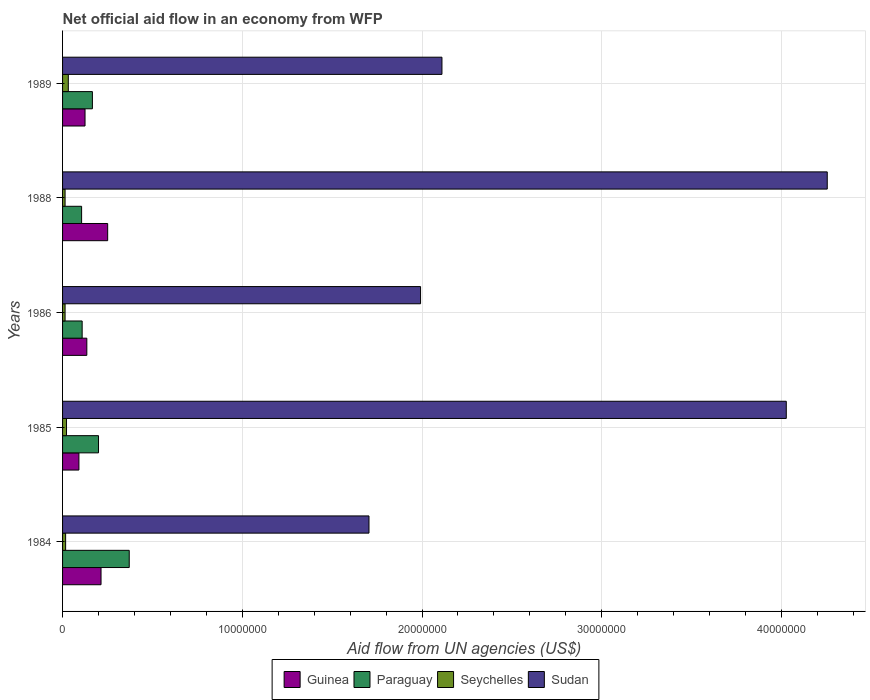Are the number of bars on each tick of the Y-axis equal?
Your answer should be very brief. Yes. What is the label of the 2nd group of bars from the top?
Ensure brevity in your answer.  1988. In how many cases, is the number of bars for a given year not equal to the number of legend labels?
Your response must be concise. 0. What is the net official aid flow in Sudan in 1988?
Give a very brief answer. 4.26e+07. Across all years, what is the maximum net official aid flow in Guinea?
Give a very brief answer. 2.51e+06. Across all years, what is the minimum net official aid flow in Guinea?
Your response must be concise. 9.10e+05. In which year was the net official aid flow in Sudan maximum?
Make the answer very short. 1988. In which year was the net official aid flow in Sudan minimum?
Your response must be concise. 1984. What is the total net official aid flow in Guinea in the graph?
Your response must be concise. 8.16e+06. What is the difference between the net official aid flow in Guinea in 1985 and that in 1988?
Provide a succinct answer. -1.60e+06. What is the difference between the net official aid flow in Sudan in 1986 and the net official aid flow in Guinea in 1984?
Make the answer very short. 1.78e+07. What is the average net official aid flow in Paraguay per year?
Offer a terse response. 1.90e+06. In the year 1984, what is the difference between the net official aid flow in Guinea and net official aid flow in Paraguay?
Your answer should be compact. -1.57e+06. In how many years, is the net official aid flow in Paraguay greater than 12000000 US$?
Keep it short and to the point. 0. What is the ratio of the net official aid flow in Seychelles in 1986 to that in 1989?
Offer a very short reply. 0.44. Is the net official aid flow in Paraguay in 1985 less than that in 1988?
Your answer should be very brief. No. Is the difference between the net official aid flow in Guinea in 1986 and 1988 greater than the difference between the net official aid flow in Paraguay in 1986 and 1988?
Provide a short and direct response. No. What is the difference between the highest and the second highest net official aid flow in Sudan?
Give a very brief answer. 2.28e+06. Is the sum of the net official aid flow in Seychelles in 1984 and 1986 greater than the maximum net official aid flow in Guinea across all years?
Provide a succinct answer. No. What does the 2nd bar from the top in 1984 represents?
Offer a terse response. Seychelles. What does the 3rd bar from the bottom in 1984 represents?
Offer a very short reply. Seychelles. How many bars are there?
Your response must be concise. 20. How many years are there in the graph?
Provide a succinct answer. 5. What is the difference between two consecutive major ticks on the X-axis?
Make the answer very short. 1.00e+07. Are the values on the major ticks of X-axis written in scientific E-notation?
Give a very brief answer. No. Does the graph contain grids?
Your answer should be very brief. Yes. How many legend labels are there?
Your answer should be very brief. 4. What is the title of the graph?
Your answer should be compact. Net official aid flow in an economy from WFP. What is the label or title of the X-axis?
Keep it short and to the point. Aid flow from UN agencies (US$). What is the label or title of the Y-axis?
Your answer should be compact. Years. What is the Aid flow from UN agencies (US$) in Guinea in 1984?
Give a very brief answer. 2.14e+06. What is the Aid flow from UN agencies (US$) of Paraguay in 1984?
Offer a very short reply. 3.71e+06. What is the Aid flow from UN agencies (US$) in Sudan in 1984?
Provide a succinct answer. 1.70e+07. What is the Aid flow from UN agencies (US$) in Guinea in 1985?
Keep it short and to the point. 9.10e+05. What is the Aid flow from UN agencies (US$) in Paraguay in 1985?
Provide a short and direct response. 2.00e+06. What is the Aid flow from UN agencies (US$) in Seychelles in 1985?
Make the answer very short. 2.20e+05. What is the Aid flow from UN agencies (US$) in Sudan in 1985?
Give a very brief answer. 4.03e+07. What is the Aid flow from UN agencies (US$) in Guinea in 1986?
Keep it short and to the point. 1.35e+06. What is the Aid flow from UN agencies (US$) in Paraguay in 1986?
Your response must be concise. 1.09e+06. What is the Aid flow from UN agencies (US$) in Seychelles in 1986?
Offer a terse response. 1.40e+05. What is the Aid flow from UN agencies (US$) of Sudan in 1986?
Your response must be concise. 1.99e+07. What is the Aid flow from UN agencies (US$) of Guinea in 1988?
Keep it short and to the point. 2.51e+06. What is the Aid flow from UN agencies (US$) in Paraguay in 1988?
Your response must be concise. 1.06e+06. What is the Aid flow from UN agencies (US$) of Seychelles in 1988?
Keep it short and to the point. 1.40e+05. What is the Aid flow from UN agencies (US$) of Sudan in 1988?
Your response must be concise. 4.26e+07. What is the Aid flow from UN agencies (US$) in Guinea in 1989?
Provide a short and direct response. 1.25e+06. What is the Aid flow from UN agencies (US$) of Paraguay in 1989?
Provide a succinct answer. 1.66e+06. What is the Aid flow from UN agencies (US$) of Sudan in 1989?
Keep it short and to the point. 2.11e+07. Across all years, what is the maximum Aid flow from UN agencies (US$) in Guinea?
Your answer should be compact. 2.51e+06. Across all years, what is the maximum Aid flow from UN agencies (US$) of Paraguay?
Your answer should be compact. 3.71e+06. Across all years, what is the maximum Aid flow from UN agencies (US$) in Sudan?
Offer a very short reply. 4.26e+07. Across all years, what is the minimum Aid flow from UN agencies (US$) of Guinea?
Ensure brevity in your answer.  9.10e+05. Across all years, what is the minimum Aid flow from UN agencies (US$) in Paraguay?
Offer a very short reply. 1.06e+06. Across all years, what is the minimum Aid flow from UN agencies (US$) in Sudan?
Your answer should be compact. 1.70e+07. What is the total Aid flow from UN agencies (US$) of Guinea in the graph?
Make the answer very short. 8.16e+06. What is the total Aid flow from UN agencies (US$) in Paraguay in the graph?
Your answer should be compact. 9.52e+06. What is the total Aid flow from UN agencies (US$) of Seychelles in the graph?
Your answer should be compact. 9.90e+05. What is the total Aid flow from UN agencies (US$) of Sudan in the graph?
Offer a terse response. 1.41e+08. What is the difference between the Aid flow from UN agencies (US$) of Guinea in 1984 and that in 1985?
Keep it short and to the point. 1.23e+06. What is the difference between the Aid flow from UN agencies (US$) of Paraguay in 1984 and that in 1985?
Give a very brief answer. 1.71e+06. What is the difference between the Aid flow from UN agencies (US$) in Sudan in 1984 and that in 1985?
Keep it short and to the point. -2.32e+07. What is the difference between the Aid flow from UN agencies (US$) in Guinea in 1984 and that in 1986?
Your answer should be very brief. 7.90e+05. What is the difference between the Aid flow from UN agencies (US$) of Paraguay in 1984 and that in 1986?
Your answer should be very brief. 2.62e+06. What is the difference between the Aid flow from UN agencies (US$) of Sudan in 1984 and that in 1986?
Provide a succinct answer. -2.87e+06. What is the difference between the Aid flow from UN agencies (US$) of Guinea in 1984 and that in 1988?
Your answer should be compact. -3.70e+05. What is the difference between the Aid flow from UN agencies (US$) in Paraguay in 1984 and that in 1988?
Your answer should be compact. 2.65e+06. What is the difference between the Aid flow from UN agencies (US$) of Sudan in 1984 and that in 1988?
Keep it short and to the point. -2.55e+07. What is the difference between the Aid flow from UN agencies (US$) of Guinea in 1984 and that in 1989?
Offer a terse response. 8.90e+05. What is the difference between the Aid flow from UN agencies (US$) of Paraguay in 1984 and that in 1989?
Offer a very short reply. 2.05e+06. What is the difference between the Aid flow from UN agencies (US$) of Sudan in 1984 and that in 1989?
Ensure brevity in your answer.  -4.06e+06. What is the difference between the Aid flow from UN agencies (US$) of Guinea in 1985 and that in 1986?
Provide a succinct answer. -4.40e+05. What is the difference between the Aid flow from UN agencies (US$) of Paraguay in 1985 and that in 1986?
Your answer should be very brief. 9.10e+05. What is the difference between the Aid flow from UN agencies (US$) of Seychelles in 1985 and that in 1986?
Provide a succinct answer. 8.00e+04. What is the difference between the Aid flow from UN agencies (US$) of Sudan in 1985 and that in 1986?
Give a very brief answer. 2.04e+07. What is the difference between the Aid flow from UN agencies (US$) of Guinea in 1985 and that in 1988?
Offer a terse response. -1.60e+06. What is the difference between the Aid flow from UN agencies (US$) in Paraguay in 1985 and that in 1988?
Offer a very short reply. 9.40e+05. What is the difference between the Aid flow from UN agencies (US$) in Seychelles in 1985 and that in 1988?
Your answer should be compact. 8.00e+04. What is the difference between the Aid flow from UN agencies (US$) in Sudan in 1985 and that in 1988?
Offer a very short reply. -2.28e+06. What is the difference between the Aid flow from UN agencies (US$) in Paraguay in 1985 and that in 1989?
Your answer should be compact. 3.40e+05. What is the difference between the Aid flow from UN agencies (US$) in Seychelles in 1985 and that in 1989?
Make the answer very short. -1.00e+05. What is the difference between the Aid flow from UN agencies (US$) in Sudan in 1985 and that in 1989?
Your response must be concise. 1.92e+07. What is the difference between the Aid flow from UN agencies (US$) in Guinea in 1986 and that in 1988?
Your response must be concise. -1.16e+06. What is the difference between the Aid flow from UN agencies (US$) in Paraguay in 1986 and that in 1988?
Your answer should be compact. 3.00e+04. What is the difference between the Aid flow from UN agencies (US$) in Sudan in 1986 and that in 1988?
Give a very brief answer. -2.26e+07. What is the difference between the Aid flow from UN agencies (US$) of Paraguay in 1986 and that in 1989?
Offer a terse response. -5.70e+05. What is the difference between the Aid flow from UN agencies (US$) of Seychelles in 1986 and that in 1989?
Your answer should be compact. -1.80e+05. What is the difference between the Aid flow from UN agencies (US$) in Sudan in 1986 and that in 1989?
Give a very brief answer. -1.19e+06. What is the difference between the Aid flow from UN agencies (US$) of Guinea in 1988 and that in 1989?
Your answer should be compact. 1.26e+06. What is the difference between the Aid flow from UN agencies (US$) in Paraguay in 1988 and that in 1989?
Give a very brief answer. -6.00e+05. What is the difference between the Aid flow from UN agencies (US$) in Sudan in 1988 and that in 1989?
Provide a short and direct response. 2.14e+07. What is the difference between the Aid flow from UN agencies (US$) in Guinea in 1984 and the Aid flow from UN agencies (US$) in Seychelles in 1985?
Provide a short and direct response. 1.92e+06. What is the difference between the Aid flow from UN agencies (US$) of Guinea in 1984 and the Aid flow from UN agencies (US$) of Sudan in 1985?
Provide a short and direct response. -3.81e+07. What is the difference between the Aid flow from UN agencies (US$) in Paraguay in 1984 and the Aid flow from UN agencies (US$) in Seychelles in 1985?
Your answer should be compact. 3.49e+06. What is the difference between the Aid flow from UN agencies (US$) of Paraguay in 1984 and the Aid flow from UN agencies (US$) of Sudan in 1985?
Give a very brief answer. -3.66e+07. What is the difference between the Aid flow from UN agencies (US$) of Seychelles in 1984 and the Aid flow from UN agencies (US$) of Sudan in 1985?
Provide a succinct answer. -4.01e+07. What is the difference between the Aid flow from UN agencies (US$) of Guinea in 1984 and the Aid flow from UN agencies (US$) of Paraguay in 1986?
Ensure brevity in your answer.  1.05e+06. What is the difference between the Aid flow from UN agencies (US$) in Guinea in 1984 and the Aid flow from UN agencies (US$) in Seychelles in 1986?
Your response must be concise. 2.00e+06. What is the difference between the Aid flow from UN agencies (US$) of Guinea in 1984 and the Aid flow from UN agencies (US$) of Sudan in 1986?
Make the answer very short. -1.78e+07. What is the difference between the Aid flow from UN agencies (US$) of Paraguay in 1984 and the Aid flow from UN agencies (US$) of Seychelles in 1986?
Your answer should be very brief. 3.57e+06. What is the difference between the Aid flow from UN agencies (US$) of Paraguay in 1984 and the Aid flow from UN agencies (US$) of Sudan in 1986?
Your answer should be compact. -1.62e+07. What is the difference between the Aid flow from UN agencies (US$) of Seychelles in 1984 and the Aid flow from UN agencies (US$) of Sudan in 1986?
Your answer should be compact. -1.98e+07. What is the difference between the Aid flow from UN agencies (US$) of Guinea in 1984 and the Aid flow from UN agencies (US$) of Paraguay in 1988?
Your response must be concise. 1.08e+06. What is the difference between the Aid flow from UN agencies (US$) of Guinea in 1984 and the Aid flow from UN agencies (US$) of Sudan in 1988?
Your answer should be very brief. -4.04e+07. What is the difference between the Aid flow from UN agencies (US$) of Paraguay in 1984 and the Aid flow from UN agencies (US$) of Seychelles in 1988?
Make the answer very short. 3.57e+06. What is the difference between the Aid flow from UN agencies (US$) in Paraguay in 1984 and the Aid flow from UN agencies (US$) in Sudan in 1988?
Your response must be concise. -3.88e+07. What is the difference between the Aid flow from UN agencies (US$) of Seychelles in 1984 and the Aid flow from UN agencies (US$) of Sudan in 1988?
Make the answer very short. -4.24e+07. What is the difference between the Aid flow from UN agencies (US$) in Guinea in 1984 and the Aid flow from UN agencies (US$) in Paraguay in 1989?
Make the answer very short. 4.80e+05. What is the difference between the Aid flow from UN agencies (US$) in Guinea in 1984 and the Aid flow from UN agencies (US$) in Seychelles in 1989?
Your answer should be compact. 1.82e+06. What is the difference between the Aid flow from UN agencies (US$) of Guinea in 1984 and the Aid flow from UN agencies (US$) of Sudan in 1989?
Provide a succinct answer. -1.90e+07. What is the difference between the Aid flow from UN agencies (US$) of Paraguay in 1984 and the Aid flow from UN agencies (US$) of Seychelles in 1989?
Offer a terse response. 3.39e+06. What is the difference between the Aid flow from UN agencies (US$) in Paraguay in 1984 and the Aid flow from UN agencies (US$) in Sudan in 1989?
Ensure brevity in your answer.  -1.74e+07. What is the difference between the Aid flow from UN agencies (US$) of Seychelles in 1984 and the Aid flow from UN agencies (US$) of Sudan in 1989?
Offer a very short reply. -2.09e+07. What is the difference between the Aid flow from UN agencies (US$) in Guinea in 1985 and the Aid flow from UN agencies (US$) in Seychelles in 1986?
Ensure brevity in your answer.  7.70e+05. What is the difference between the Aid flow from UN agencies (US$) in Guinea in 1985 and the Aid flow from UN agencies (US$) in Sudan in 1986?
Keep it short and to the point. -1.90e+07. What is the difference between the Aid flow from UN agencies (US$) in Paraguay in 1985 and the Aid flow from UN agencies (US$) in Seychelles in 1986?
Give a very brief answer. 1.86e+06. What is the difference between the Aid flow from UN agencies (US$) of Paraguay in 1985 and the Aid flow from UN agencies (US$) of Sudan in 1986?
Offer a very short reply. -1.79e+07. What is the difference between the Aid flow from UN agencies (US$) in Seychelles in 1985 and the Aid flow from UN agencies (US$) in Sudan in 1986?
Your answer should be very brief. -1.97e+07. What is the difference between the Aid flow from UN agencies (US$) of Guinea in 1985 and the Aid flow from UN agencies (US$) of Seychelles in 1988?
Provide a short and direct response. 7.70e+05. What is the difference between the Aid flow from UN agencies (US$) of Guinea in 1985 and the Aid flow from UN agencies (US$) of Sudan in 1988?
Give a very brief answer. -4.16e+07. What is the difference between the Aid flow from UN agencies (US$) in Paraguay in 1985 and the Aid flow from UN agencies (US$) in Seychelles in 1988?
Your answer should be very brief. 1.86e+06. What is the difference between the Aid flow from UN agencies (US$) of Paraguay in 1985 and the Aid flow from UN agencies (US$) of Sudan in 1988?
Your answer should be compact. -4.06e+07. What is the difference between the Aid flow from UN agencies (US$) in Seychelles in 1985 and the Aid flow from UN agencies (US$) in Sudan in 1988?
Offer a terse response. -4.23e+07. What is the difference between the Aid flow from UN agencies (US$) in Guinea in 1985 and the Aid flow from UN agencies (US$) in Paraguay in 1989?
Provide a succinct answer. -7.50e+05. What is the difference between the Aid flow from UN agencies (US$) in Guinea in 1985 and the Aid flow from UN agencies (US$) in Seychelles in 1989?
Provide a succinct answer. 5.90e+05. What is the difference between the Aid flow from UN agencies (US$) in Guinea in 1985 and the Aid flow from UN agencies (US$) in Sudan in 1989?
Provide a short and direct response. -2.02e+07. What is the difference between the Aid flow from UN agencies (US$) of Paraguay in 1985 and the Aid flow from UN agencies (US$) of Seychelles in 1989?
Offer a terse response. 1.68e+06. What is the difference between the Aid flow from UN agencies (US$) of Paraguay in 1985 and the Aid flow from UN agencies (US$) of Sudan in 1989?
Make the answer very short. -1.91e+07. What is the difference between the Aid flow from UN agencies (US$) of Seychelles in 1985 and the Aid flow from UN agencies (US$) of Sudan in 1989?
Your answer should be compact. -2.09e+07. What is the difference between the Aid flow from UN agencies (US$) in Guinea in 1986 and the Aid flow from UN agencies (US$) in Seychelles in 1988?
Make the answer very short. 1.21e+06. What is the difference between the Aid flow from UN agencies (US$) of Guinea in 1986 and the Aid flow from UN agencies (US$) of Sudan in 1988?
Make the answer very short. -4.12e+07. What is the difference between the Aid flow from UN agencies (US$) of Paraguay in 1986 and the Aid flow from UN agencies (US$) of Seychelles in 1988?
Offer a terse response. 9.50e+05. What is the difference between the Aid flow from UN agencies (US$) of Paraguay in 1986 and the Aid flow from UN agencies (US$) of Sudan in 1988?
Give a very brief answer. -4.15e+07. What is the difference between the Aid flow from UN agencies (US$) in Seychelles in 1986 and the Aid flow from UN agencies (US$) in Sudan in 1988?
Offer a very short reply. -4.24e+07. What is the difference between the Aid flow from UN agencies (US$) of Guinea in 1986 and the Aid flow from UN agencies (US$) of Paraguay in 1989?
Provide a succinct answer. -3.10e+05. What is the difference between the Aid flow from UN agencies (US$) in Guinea in 1986 and the Aid flow from UN agencies (US$) in Seychelles in 1989?
Offer a terse response. 1.03e+06. What is the difference between the Aid flow from UN agencies (US$) in Guinea in 1986 and the Aid flow from UN agencies (US$) in Sudan in 1989?
Give a very brief answer. -1.98e+07. What is the difference between the Aid flow from UN agencies (US$) in Paraguay in 1986 and the Aid flow from UN agencies (US$) in Seychelles in 1989?
Your response must be concise. 7.70e+05. What is the difference between the Aid flow from UN agencies (US$) of Paraguay in 1986 and the Aid flow from UN agencies (US$) of Sudan in 1989?
Ensure brevity in your answer.  -2.00e+07. What is the difference between the Aid flow from UN agencies (US$) in Seychelles in 1986 and the Aid flow from UN agencies (US$) in Sudan in 1989?
Keep it short and to the point. -2.10e+07. What is the difference between the Aid flow from UN agencies (US$) in Guinea in 1988 and the Aid flow from UN agencies (US$) in Paraguay in 1989?
Provide a succinct answer. 8.50e+05. What is the difference between the Aid flow from UN agencies (US$) in Guinea in 1988 and the Aid flow from UN agencies (US$) in Seychelles in 1989?
Offer a very short reply. 2.19e+06. What is the difference between the Aid flow from UN agencies (US$) of Guinea in 1988 and the Aid flow from UN agencies (US$) of Sudan in 1989?
Keep it short and to the point. -1.86e+07. What is the difference between the Aid flow from UN agencies (US$) in Paraguay in 1988 and the Aid flow from UN agencies (US$) in Seychelles in 1989?
Provide a succinct answer. 7.40e+05. What is the difference between the Aid flow from UN agencies (US$) in Paraguay in 1988 and the Aid flow from UN agencies (US$) in Sudan in 1989?
Offer a terse response. -2.00e+07. What is the difference between the Aid flow from UN agencies (US$) of Seychelles in 1988 and the Aid flow from UN agencies (US$) of Sudan in 1989?
Offer a very short reply. -2.10e+07. What is the average Aid flow from UN agencies (US$) in Guinea per year?
Offer a very short reply. 1.63e+06. What is the average Aid flow from UN agencies (US$) of Paraguay per year?
Your answer should be compact. 1.90e+06. What is the average Aid flow from UN agencies (US$) of Seychelles per year?
Your answer should be very brief. 1.98e+05. What is the average Aid flow from UN agencies (US$) of Sudan per year?
Your response must be concise. 2.82e+07. In the year 1984, what is the difference between the Aid flow from UN agencies (US$) of Guinea and Aid flow from UN agencies (US$) of Paraguay?
Make the answer very short. -1.57e+06. In the year 1984, what is the difference between the Aid flow from UN agencies (US$) in Guinea and Aid flow from UN agencies (US$) in Seychelles?
Your answer should be compact. 1.97e+06. In the year 1984, what is the difference between the Aid flow from UN agencies (US$) in Guinea and Aid flow from UN agencies (US$) in Sudan?
Provide a short and direct response. -1.49e+07. In the year 1984, what is the difference between the Aid flow from UN agencies (US$) of Paraguay and Aid flow from UN agencies (US$) of Seychelles?
Give a very brief answer. 3.54e+06. In the year 1984, what is the difference between the Aid flow from UN agencies (US$) in Paraguay and Aid flow from UN agencies (US$) in Sudan?
Ensure brevity in your answer.  -1.33e+07. In the year 1984, what is the difference between the Aid flow from UN agencies (US$) of Seychelles and Aid flow from UN agencies (US$) of Sudan?
Your answer should be very brief. -1.69e+07. In the year 1985, what is the difference between the Aid flow from UN agencies (US$) in Guinea and Aid flow from UN agencies (US$) in Paraguay?
Keep it short and to the point. -1.09e+06. In the year 1985, what is the difference between the Aid flow from UN agencies (US$) in Guinea and Aid flow from UN agencies (US$) in Seychelles?
Keep it short and to the point. 6.90e+05. In the year 1985, what is the difference between the Aid flow from UN agencies (US$) in Guinea and Aid flow from UN agencies (US$) in Sudan?
Ensure brevity in your answer.  -3.94e+07. In the year 1985, what is the difference between the Aid flow from UN agencies (US$) of Paraguay and Aid flow from UN agencies (US$) of Seychelles?
Ensure brevity in your answer.  1.78e+06. In the year 1985, what is the difference between the Aid flow from UN agencies (US$) of Paraguay and Aid flow from UN agencies (US$) of Sudan?
Your response must be concise. -3.83e+07. In the year 1985, what is the difference between the Aid flow from UN agencies (US$) in Seychelles and Aid flow from UN agencies (US$) in Sudan?
Ensure brevity in your answer.  -4.00e+07. In the year 1986, what is the difference between the Aid flow from UN agencies (US$) in Guinea and Aid flow from UN agencies (US$) in Paraguay?
Provide a succinct answer. 2.60e+05. In the year 1986, what is the difference between the Aid flow from UN agencies (US$) of Guinea and Aid flow from UN agencies (US$) of Seychelles?
Keep it short and to the point. 1.21e+06. In the year 1986, what is the difference between the Aid flow from UN agencies (US$) in Guinea and Aid flow from UN agencies (US$) in Sudan?
Keep it short and to the point. -1.86e+07. In the year 1986, what is the difference between the Aid flow from UN agencies (US$) of Paraguay and Aid flow from UN agencies (US$) of Seychelles?
Give a very brief answer. 9.50e+05. In the year 1986, what is the difference between the Aid flow from UN agencies (US$) in Paraguay and Aid flow from UN agencies (US$) in Sudan?
Offer a very short reply. -1.88e+07. In the year 1986, what is the difference between the Aid flow from UN agencies (US$) in Seychelles and Aid flow from UN agencies (US$) in Sudan?
Offer a terse response. -1.98e+07. In the year 1988, what is the difference between the Aid flow from UN agencies (US$) in Guinea and Aid flow from UN agencies (US$) in Paraguay?
Your answer should be compact. 1.45e+06. In the year 1988, what is the difference between the Aid flow from UN agencies (US$) in Guinea and Aid flow from UN agencies (US$) in Seychelles?
Offer a terse response. 2.37e+06. In the year 1988, what is the difference between the Aid flow from UN agencies (US$) of Guinea and Aid flow from UN agencies (US$) of Sudan?
Keep it short and to the point. -4.00e+07. In the year 1988, what is the difference between the Aid flow from UN agencies (US$) in Paraguay and Aid flow from UN agencies (US$) in Seychelles?
Provide a succinct answer. 9.20e+05. In the year 1988, what is the difference between the Aid flow from UN agencies (US$) of Paraguay and Aid flow from UN agencies (US$) of Sudan?
Give a very brief answer. -4.15e+07. In the year 1988, what is the difference between the Aid flow from UN agencies (US$) of Seychelles and Aid flow from UN agencies (US$) of Sudan?
Your answer should be compact. -4.24e+07. In the year 1989, what is the difference between the Aid flow from UN agencies (US$) of Guinea and Aid flow from UN agencies (US$) of Paraguay?
Ensure brevity in your answer.  -4.10e+05. In the year 1989, what is the difference between the Aid flow from UN agencies (US$) in Guinea and Aid flow from UN agencies (US$) in Seychelles?
Ensure brevity in your answer.  9.30e+05. In the year 1989, what is the difference between the Aid flow from UN agencies (US$) in Guinea and Aid flow from UN agencies (US$) in Sudan?
Your answer should be compact. -1.99e+07. In the year 1989, what is the difference between the Aid flow from UN agencies (US$) of Paraguay and Aid flow from UN agencies (US$) of Seychelles?
Your answer should be compact. 1.34e+06. In the year 1989, what is the difference between the Aid flow from UN agencies (US$) in Paraguay and Aid flow from UN agencies (US$) in Sudan?
Give a very brief answer. -1.94e+07. In the year 1989, what is the difference between the Aid flow from UN agencies (US$) in Seychelles and Aid flow from UN agencies (US$) in Sudan?
Ensure brevity in your answer.  -2.08e+07. What is the ratio of the Aid flow from UN agencies (US$) of Guinea in 1984 to that in 1985?
Provide a short and direct response. 2.35. What is the ratio of the Aid flow from UN agencies (US$) of Paraguay in 1984 to that in 1985?
Ensure brevity in your answer.  1.85. What is the ratio of the Aid flow from UN agencies (US$) of Seychelles in 1984 to that in 1985?
Offer a very short reply. 0.77. What is the ratio of the Aid flow from UN agencies (US$) in Sudan in 1984 to that in 1985?
Keep it short and to the point. 0.42. What is the ratio of the Aid flow from UN agencies (US$) in Guinea in 1984 to that in 1986?
Your answer should be compact. 1.59. What is the ratio of the Aid flow from UN agencies (US$) in Paraguay in 1984 to that in 1986?
Give a very brief answer. 3.4. What is the ratio of the Aid flow from UN agencies (US$) of Seychelles in 1984 to that in 1986?
Your answer should be very brief. 1.21. What is the ratio of the Aid flow from UN agencies (US$) of Sudan in 1984 to that in 1986?
Offer a terse response. 0.86. What is the ratio of the Aid flow from UN agencies (US$) in Guinea in 1984 to that in 1988?
Offer a very short reply. 0.85. What is the ratio of the Aid flow from UN agencies (US$) in Paraguay in 1984 to that in 1988?
Make the answer very short. 3.5. What is the ratio of the Aid flow from UN agencies (US$) of Seychelles in 1984 to that in 1988?
Make the answer very short. 1.21. What is the ratio of the Aid flow from UN agencies (US$) of Sudan in 1984 to that in 1988?
Give a very brief answer. 0.4. What is the ratio of the Aid flow from UN agencies (US$) of Guinea in 1984 to that in 1989?
Offer a terse response. 1.71. What is the ratio of the Aid flow from UN agencies (US$) in Paraguay in 1984 to that in 1989?
Provide a succinct answer. 2.23. What is the ratio of the Aid flow from UN agencies (US$) of Seychelles in 1984 to that in 1989?
Make the answer very short. 0.53. What is the ratio of the Aid flow from UN agencies (US$) in Sudan in 1984 to that in 1989?
Give a very brief answer. 0.81. What is the ratio of the Aid flow from UN agencies (US$) of Guinea in 1985 to that in 1986?
Offer a terse response. 0.67. What is the ratio of the Aid flow from UN agencies (US$) of Paraguay in 1985 to that in 1986?
Offer a terse response. 1.83. What is the ratio of the Aid flow from UN agencies (US$) in Seychelles in 1985 to that in 1986?
Ensure brevity in your answer.  1.57. What is the ratio of the Aid flow from UN agencies (US$) in Sudan in 1985 to that in 1986?
Your answer should be compact. 2.02. What is the ratio of the Aid flow from UN agencies (US$) of Guinea in 1985 to that in 1988?
Your answer should be very brief. 0.36. What is the ratio of the Aid flow from UN agencies (US$) of Paraguay in 1985 to that in 1988?
Your answer should be compact. 1.89. What is the ratio of the Aid flow from UN agencies (US$) in Seychelles in 1985 to that in 1988?
Make the answer very short. 1.57. What is the ratio of the Aid flow from UN agencies (US$) in Sudan in 1985 to that in 1988?
Make the answer very short. 0.95. What is the ratio of the Aid flow from UN agencies (US$) of Guinea in 1985 to that in 1989?
Offer a terse response. 0.73. What is the ratio of the Aid flow from UN agencies (US$) in Paraguay in 1985 to that in 1989?
Your response must be concise. 1.2. What is the ratio of the Aid flow from UN agencies (US$) in Seychelles in 1985 to that in 1989?
Offer a very short reply. 0.69. What is the ratio of the Aid flow from UN agencies (US$) in Sudan in 1985 to that in 1989?
Give a very brief answer. 1.91. What is the ratio of the Aid flow from UN agencies (US$) in Guinea in 1986 to that in 1988?
Provide a short and direct response. 0.54. What is the ratio of the Aid flow from UN agencies (US$) of Paraguay in 1986 to that in 1988?
Keep it short and to the point. 1.03. What is the ratio of the Aid flow from UN agencies (US$) in Sudan in 1986 to that in 1988?
Ensure brevity in your answer.  0.47. What is the ratio of the Aid flow from UN agencies (US$) of Guinea in 1986 to that in 1989?
Offer a very short reply. 1.08. What is the ratio of the Aid flow from UN agencies (US$) in Paraguay in 1986 to that in 1989?
Make the answer very short. 0.66. What is the ratio of the Aid flow from UN agencies (US$) of Seychelles in 1986 to that in 1989?
Give a very brief answer. 0.44. What is the ratio of the Aid flow from UN agencies (US$) of Sudan in 1986 to that in 1989?
Provide a short and direct response. 0.94. What is the ratio of the Aid flow from UN agencies (US$) in Guinea in 1988 to that in 1989?
Your response must be concise. 2.01. What is the ratio of the Aid flow from UN agencies (US$) of Paraguay in 1988 to that in 1989?
Your answer should be very brief. 0.64. What is the ratio of the Aid flow from UN agencies (US$) of Seychelles in 1988 to that in 1989?
Provide a short and direct response. 0.44. What is the ratio of the Aid flow from UN agencies (US$) in Sudan in 1988 to that in 1989?
Keep it short and to the point. 2.02. What is the difference between the highest and the second highest Aid flow from UN agencies (US$) in Paraguay?
Make the answer very short. 1.71e+06. What is the difference between the highest and the second highest Aid flow from UN agencies (US$) of Sudan?
Your answer should be very brief. 2.28e+06. What is the difference between the highest and the lowest Aid flow from UN agencies (US$) in Guinea?
Your response must be concise. 1.60e+06. What is the difference between the highest and the lowest Aid flow from UN agencies (US$) in Paraguay?
Offer a very short reply. 2.65e+06. What is the difference between the highest and the lowest Aid flow from UN agencies (US$) in Seychelles?
Your answer should be compact. 1.80e+05. What is the difference between the highest and the lowest Aid flow from UN agencies (US$) in Sudan?
Your response must be concise. 2.55e+07. 